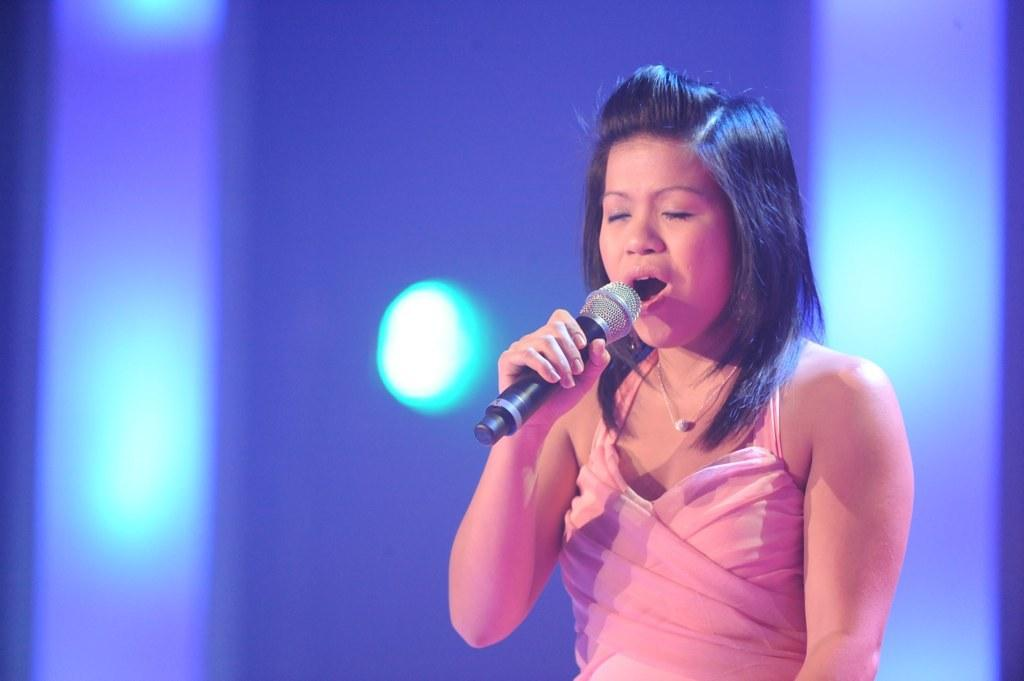Who is the main subject in the image? There is a woman in the image. What is the woman holding in the image? The woman is holding a microphone. What is the woman doing in the image? The woman is singing. How can we tell that the woman is singing? The woman's mouth is widely open, which suggests she is singing. Can you tell me how many instruments the woman is playing in the image? There is no instrument present in the image; the woman is holding a microphone and singing. Is the woman pulling anything in the image? There is no indication in the image that the woman is pulling anything. 